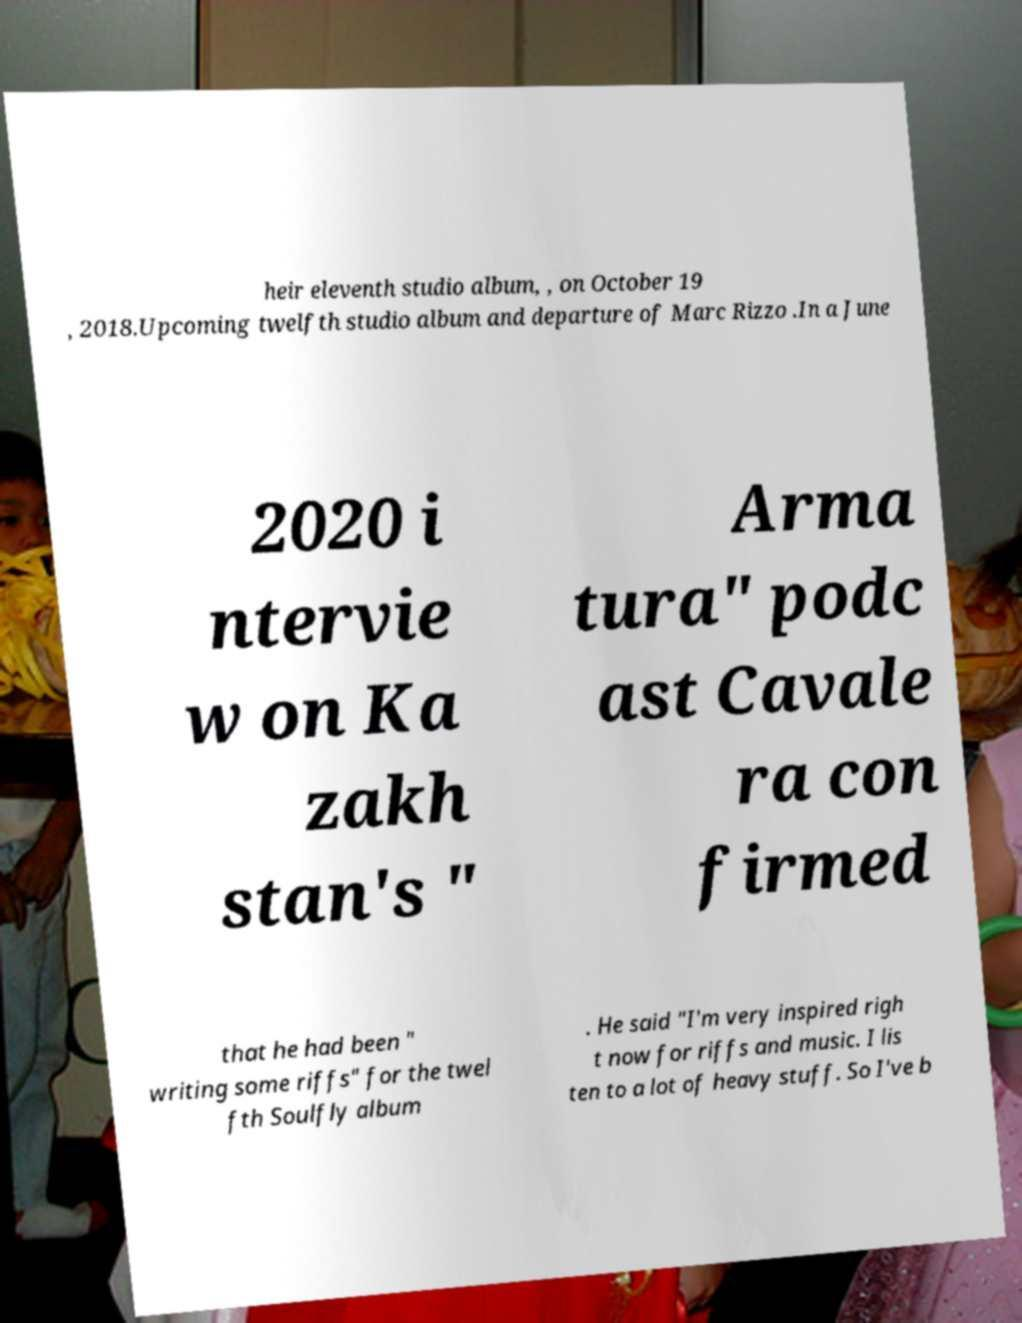Could you assist in decoding the text presented in this image and type it out clearly? heir eleventh studio album, , on October 19 , 2018.Upcoming twelfth studio album and departure of Marc Rizzo .In a June 2020 i ntervie w on Ka zakh stan's " Arma tura" podc ast Cavale ra con firmed that he had been " writing some riffs" for the twel fth Soulfly album . He said "I'm very inspired righ t now for riffs and music. I lis ten to a lot of heavy stuff. So I've b 